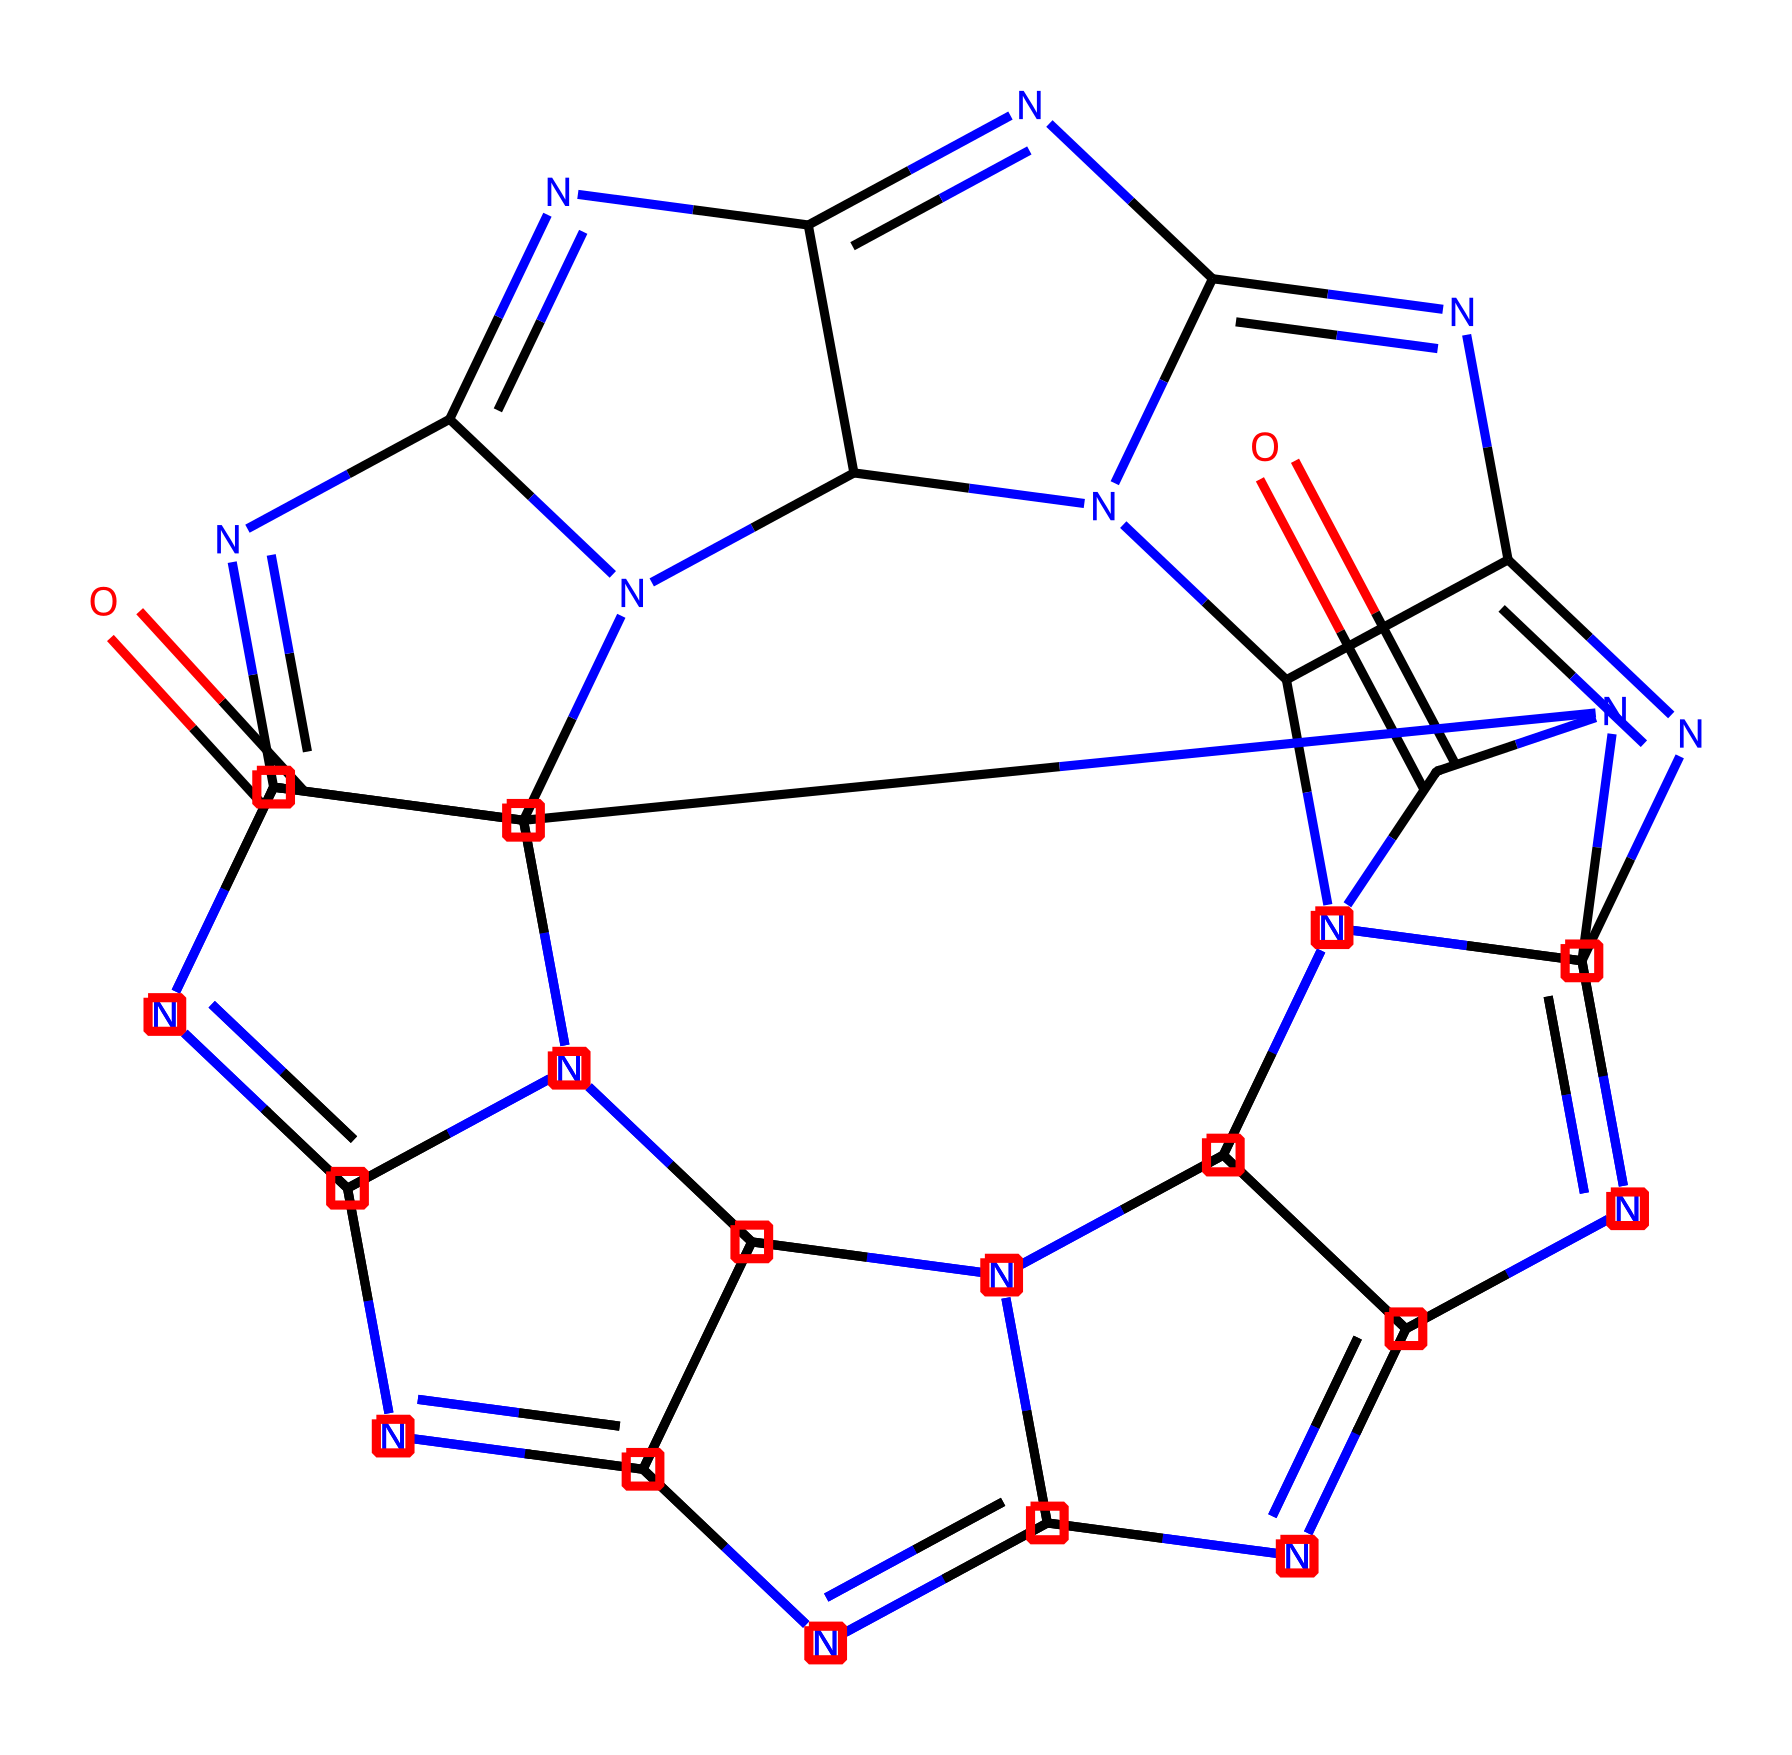What is the name of the molecular cage structure in this compound? The molecular cage structure here is known as cucurbit[7]uril, which is indicated by the unique arrangement of the atoms forming a cavity in the chemical structure.
Answer: cucurbit[7]uril How many nitrogen atoms are present in this chemical structure? By examining the SMILES representation, we can count the number of occurrences of the letter "N," which represents nitrogen. There are a total of 16 nitrogen atoms in the structure.
Answer: 16 What type of compound is cucurbit[7]uril classified as? This compound belongs to the class of "cage compounds," identifiable by its hollow molecular structure that can encapsulate other molecules, which is a characteristic feature of this chemical type.
Answer: cage compound What is the primary function of cucurbit[7]uril in water treatment systems? Cucurbit[7]uril is often used to selectively capture and remove pollutants or contaminants from water, utilizing its molecular cavity to encapsulate harmful substances and facilitate their removal.
Answer: pollutant removal How does the structure of cucurbit[7]uril contribute to its function in trapping molecules? The unique molecular architecture, which consists of a cavity surrounded by the nitrogen and carbon atoms, allows cucurbit[7]uril to effectively bind and encapsulate guest molecules, significantly enhancing its trapping capabilities.
Answer: effective binding 